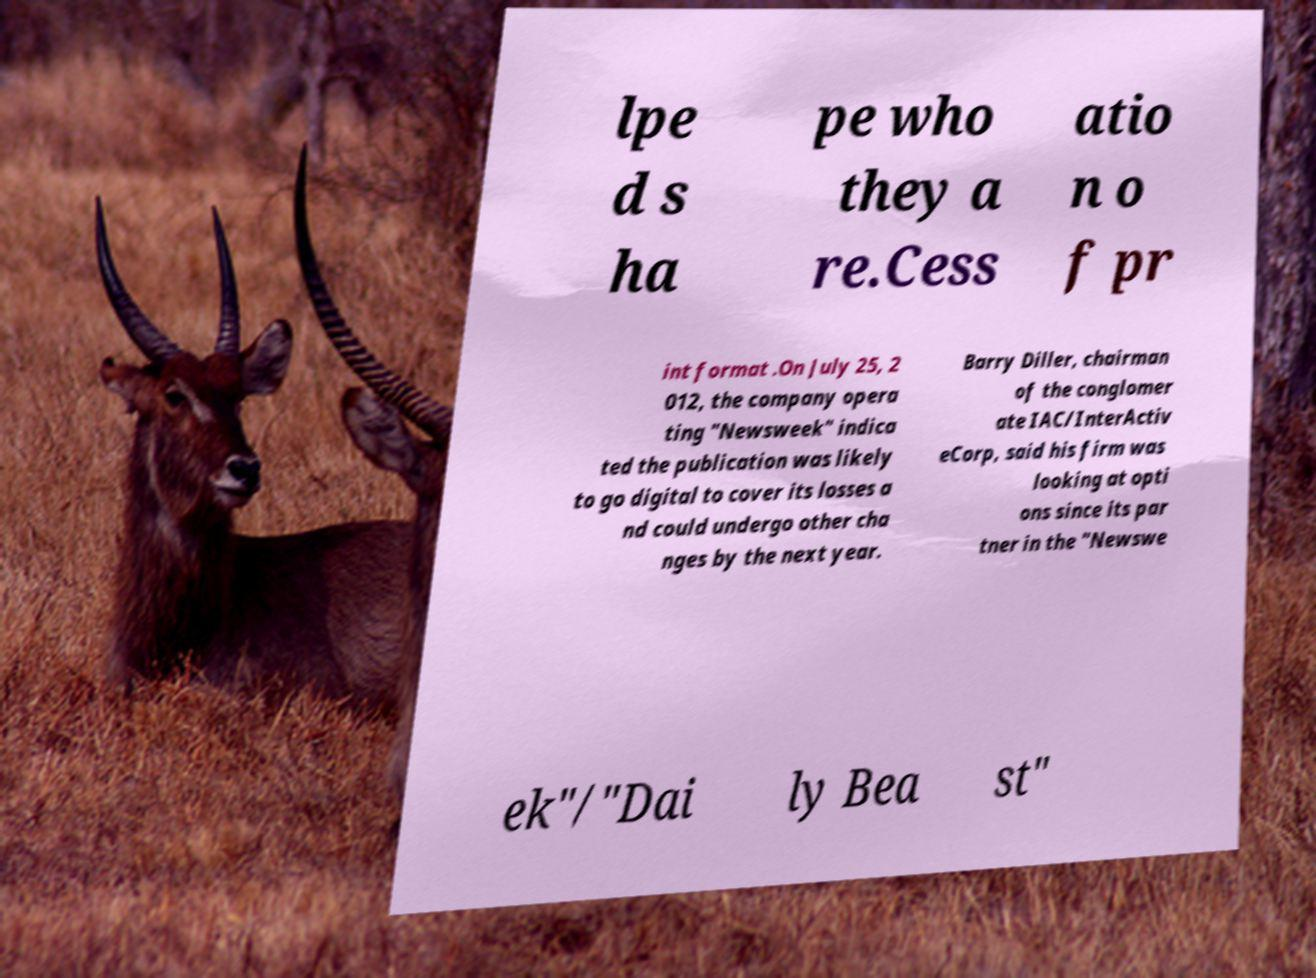Could you assist in decoding the text presented in this image and type it out clearly? lpe d s ha pe who they a re.Cess atio n o f pr int format .On July 25, 2 012, the company opera ting "Newsweek" indica ted the publication was likely to go digital to cover its losses a nd could undergo other cha nges by the next year. Barry Diller, chairman of the conglomer ate IAC/InterActiv eCorp, said his firm was looking at opti ons since its par tner in the "Newswe ek"/"Dai ly Bea st" 